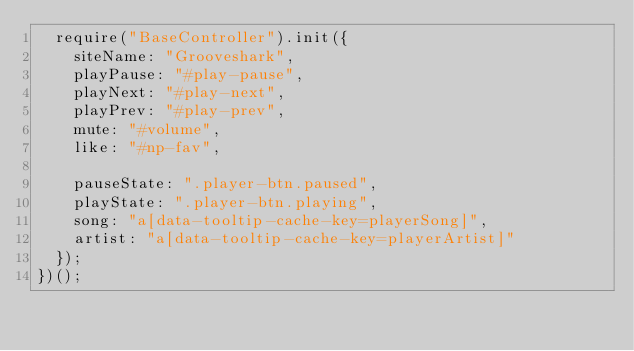Convert code to text. <code><loc_0><loc_0><loc_500><loc_500><_JavaScript_>  require("BaseController").init({
    siteName: "Grooveshark",
    playPause: "#play-pause",
    playNext: "#play-next",
    playPrev: "#play-prev",
    mute: "#volume",
    like: "#np-fav",

    pauseState: ".player-btn.paused",
    playState: ".player-btn.playing",
    song: "a[data-tooltip-cache-key=playerSong]",
    artist: "a[data-tooltip-cache-key=playerArtist]"
  });
})();
</code> 